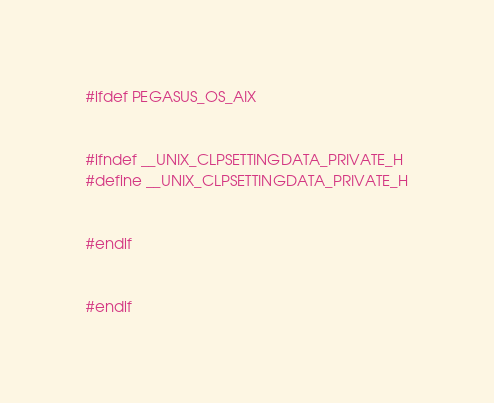<code> <loc_0><loc_0><loc_500><loc_500><_C++_>#ifdef PEGASUS_OS_AIX


#ifndef __UNIX_CLPSETTINGDATA_PRIVATE_H
#define __UNIX_CLPSETTINGDATA_PRIVATE_H


#endif


#endif
</code> 